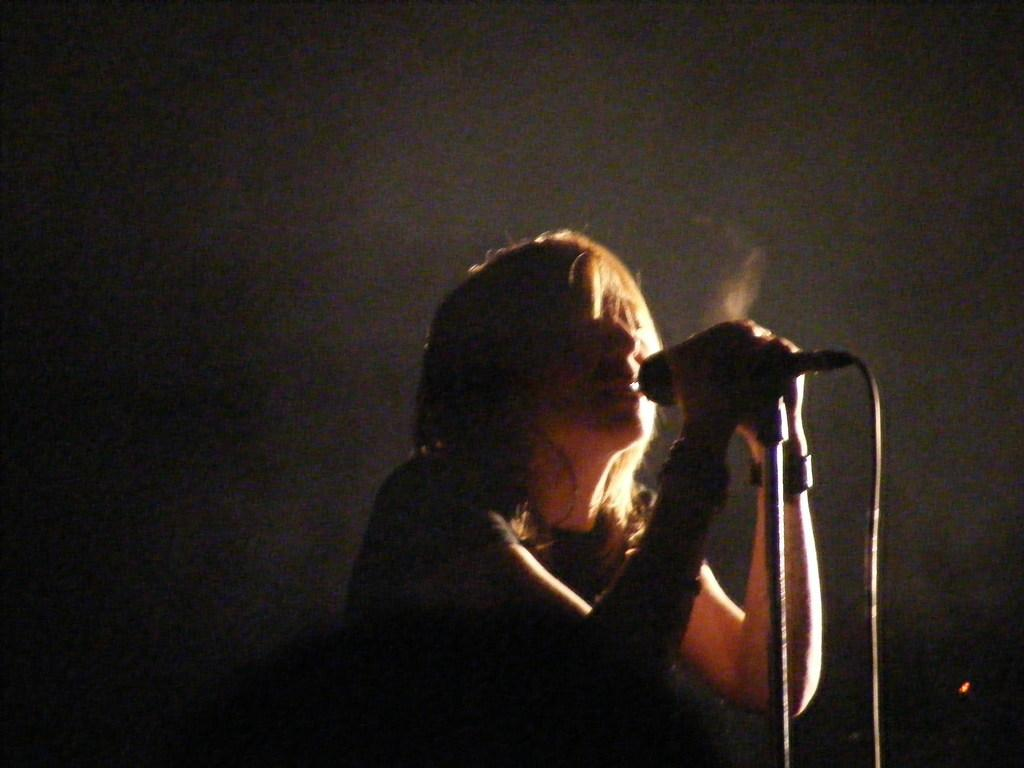Who is the main subject in the image? There is a woman in the image. What is the woman holding in the image? The woman is holding a mic and a mic stand. What is the woman doing in the image? The woman is singing. What scientific experiment is the woman conducting in the image? There is no scientific experiment being conducted in the image; the woman is singing with a mic and a mic stand. 